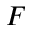<formula> <loc_0><loc_0><loc_500><loc_500>F</formula> 